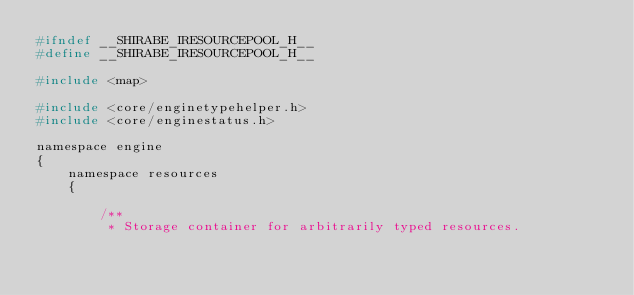<code> <loc_0><loc_0><loc_500><loc_500><_C_>#ifndef __SHIRABE_IRESOURCEPOOL_H__
#define __SHIRABE_IRESOURCEPOOL_H__

#include <map>

#include <core/enginetypehelper.h>
#include <core/enginestatus.h>

namespace engine
{
    namespace resources
    {

        /**
         * Storage container for arbitrarily typed resources.</code> 